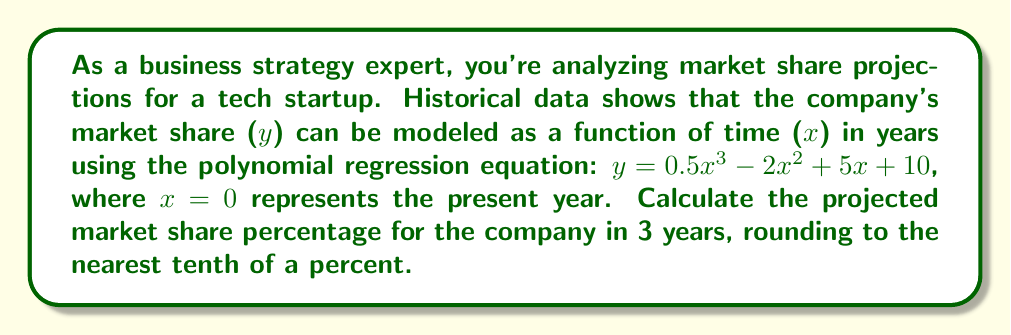Can you solve this math problem? To solve this problem, we'll follow these steps:

1) We have the polynomial regression equation:
   $y = 0.5x^3 - 2x^2 + 5x + 10$

2) We need to calculate the market share for x = 3 (3 years from now):
   $y = 0.5(3)^3 - 2(3)^2 + 5(3) + 10$

3) Let's calculate each term:
   $0.5(3)^3 = 0.5 * 27 = 13.5$
   $-2(3)^2 = -2 * 9 = -18$
   $5(3) = 15$
   $10$ remains as is

4) Now, let's sum these terms:
   $y = 13.5 - 18 + 15 + 10 = 20.5$

5) The question asks for the percentage rounded to the nearest tenth, so our final answer is 20.5%.
Answer: 20.5% 